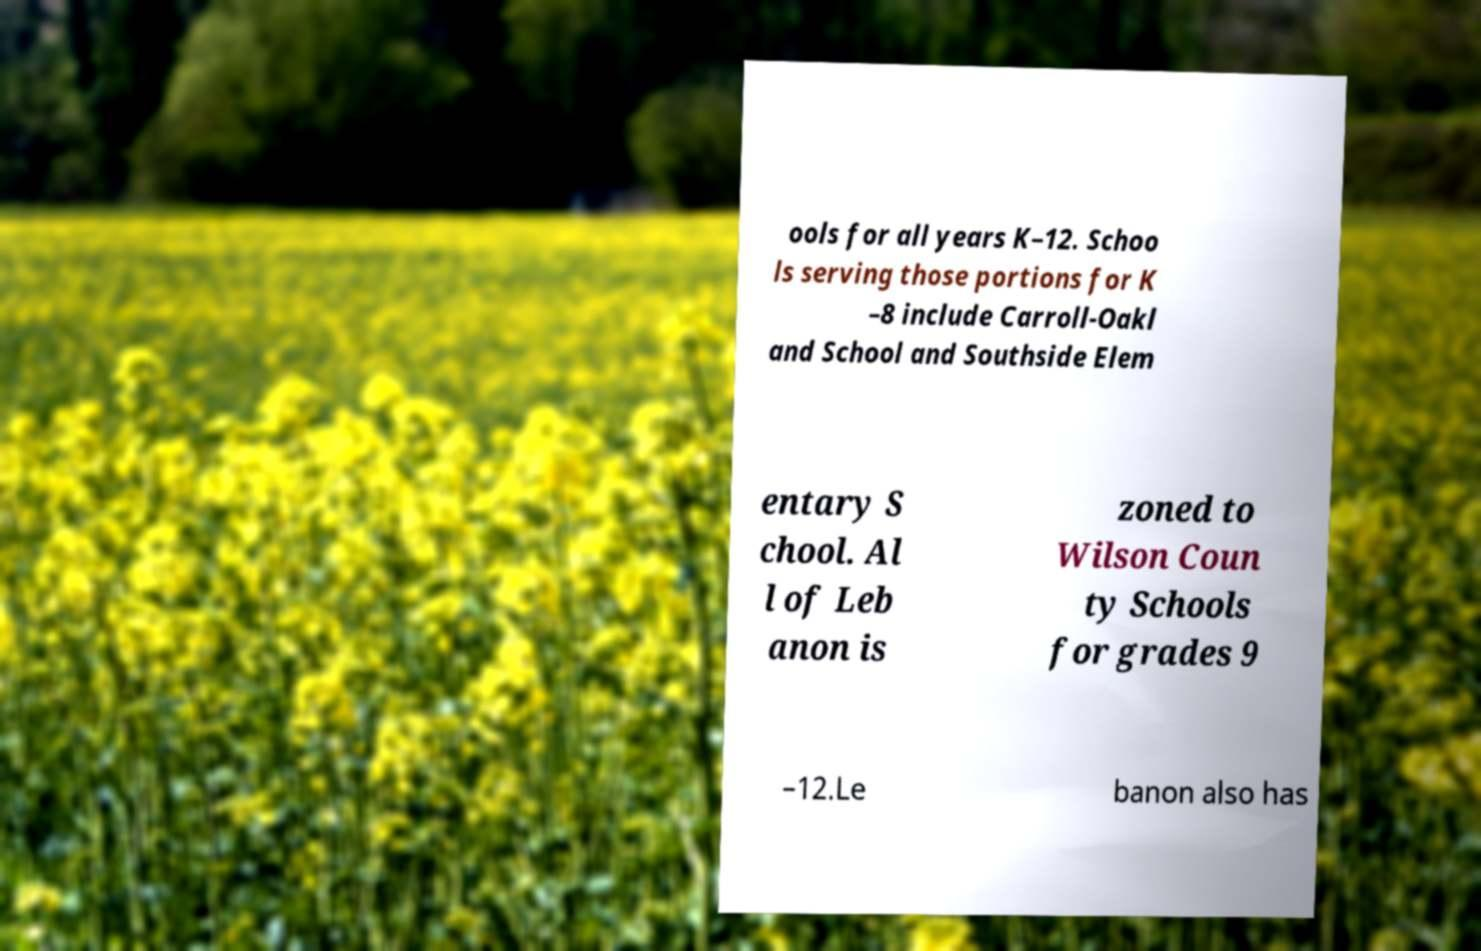There's text embedded in this image that I need extracted. Can you transcribe it verbatim? ools for all years K–12. Schoo ls serving those portions for K –8 include Carroll-Oakl and School and Southside Elem entary S chool. Al l of Leb anon is zoned to Wilson Coun ty Schools for grades 9 –12.Le banon also has 